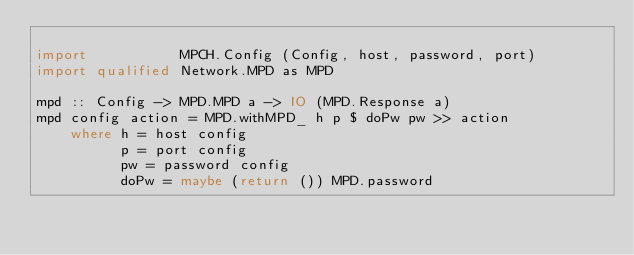Convert code to text. <code><loc_0><loc_0><loc_500><loc_500><_Haskell_>
import           MPCH.Config (Config, host, password, port)
import qualified Network.MPD as MPD

mpd :: Config -> MPD.MPD a -> IO (MPD.Response a)
mpd config action = MPD.withMPD_ h p $ doPw pw >> action
    where h = host config
          p = port config
          pw = password config
          doPw = maybe (return ()) MPD.password
</code> 